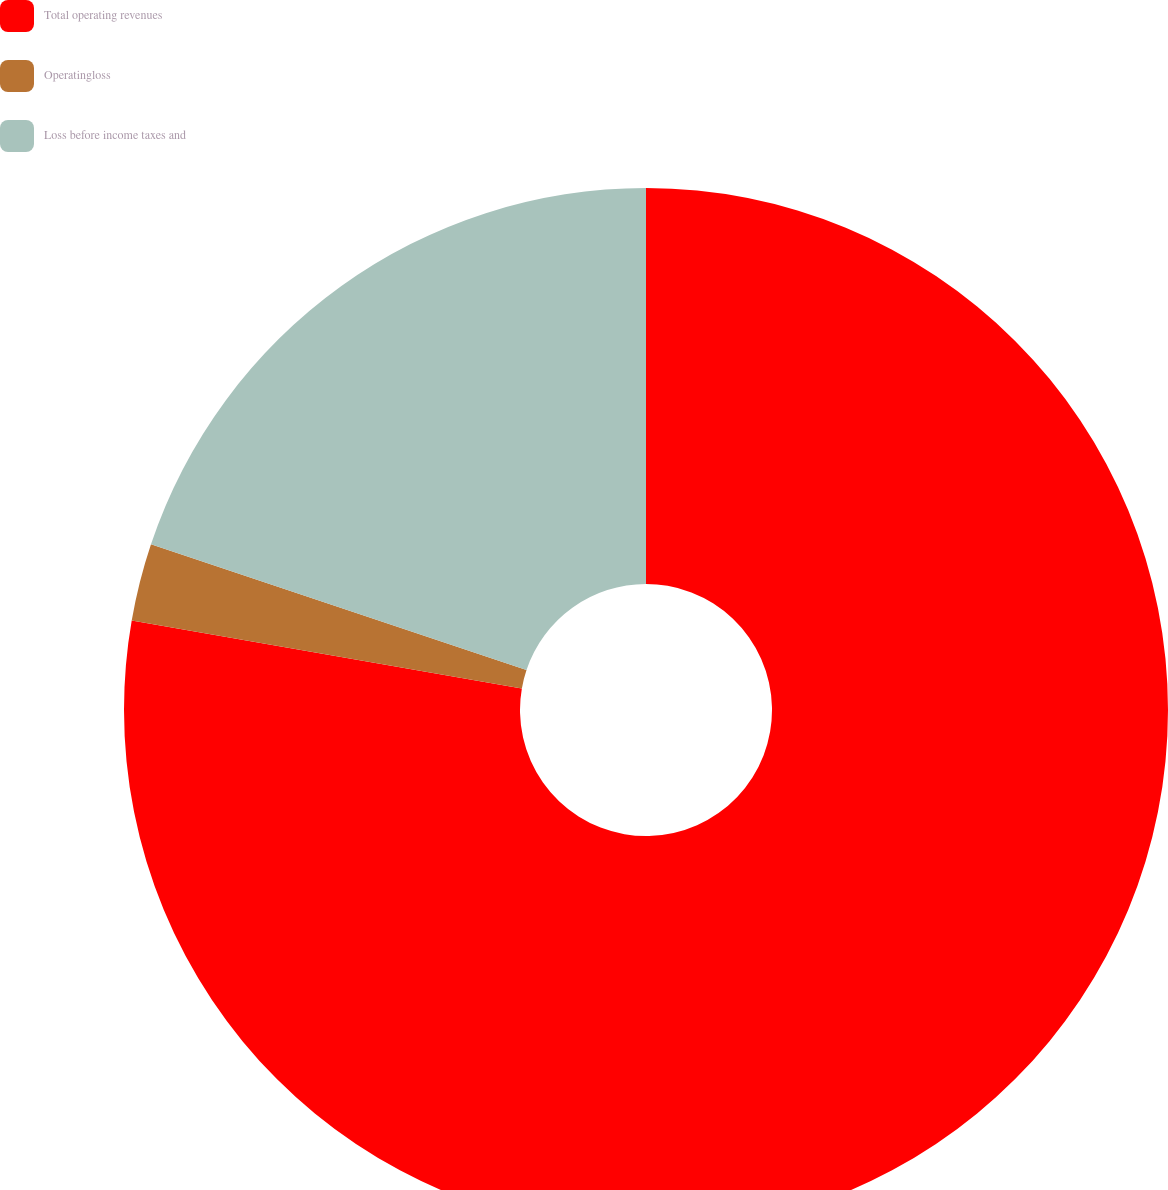Convert chart. <chart><loc_0><loc_0><loc_500><loc_500><pie_chart><fcel>Total operating revenues<fcel>Operatingloss<fcel>Loss before income taxes and<nl><fcel>77.74%<fcel>2.4%<fcel>19.86%<nl></chart> 